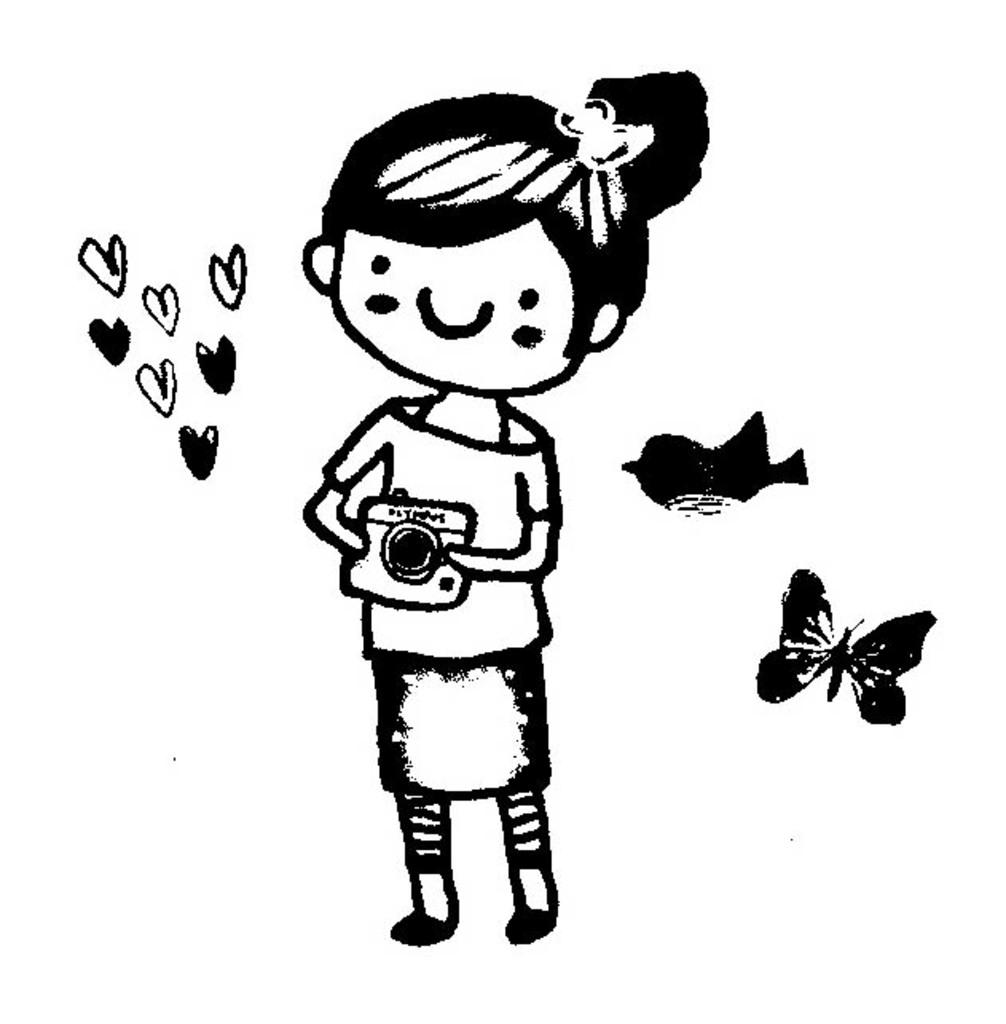What type of picture is in the image? There is a cartoon picture in the image. What animals are present in the image? There is a bird and a butterfly in the image. What is the color of the background in the image? The background of the image is white. How much salt is on the bird's beak in the image? There is no salt present in the image, and the bird's beak is not visible. 